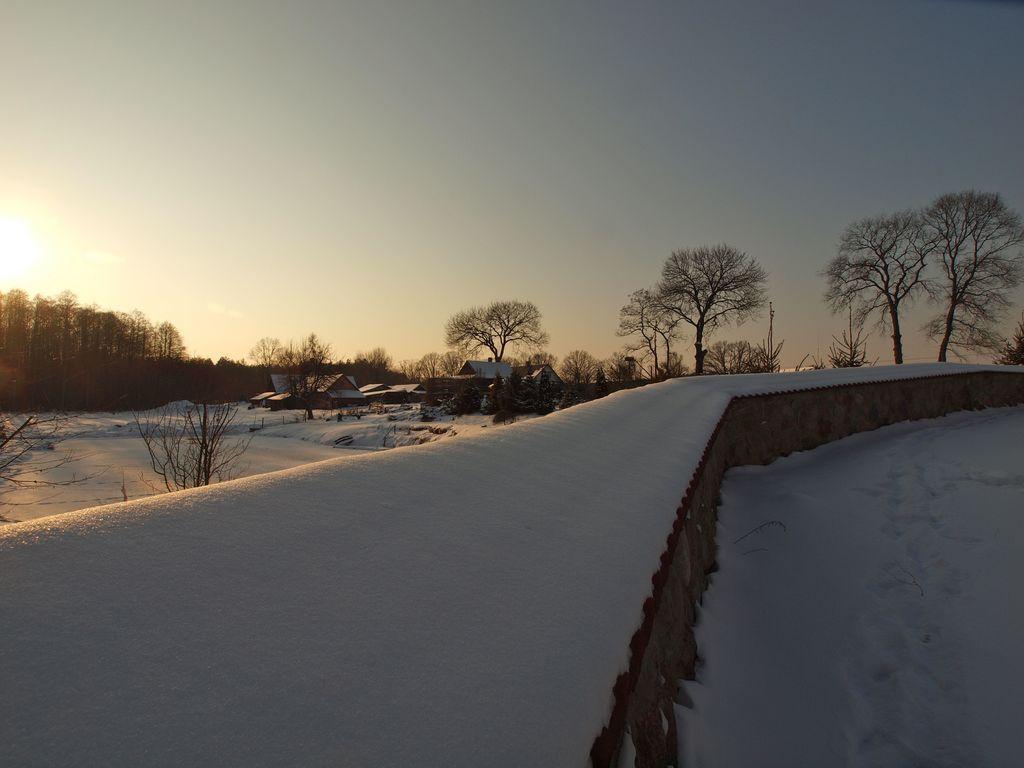Can you describe this image briefly? In this image we can see a wall covered with the snow. On the backside we can see a group of houses with roof, a group of trees, the sun and the sky which looks cloudy. 